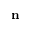<formula> <loc_0><loc_0><loc_500><loc_500>n</formula> 